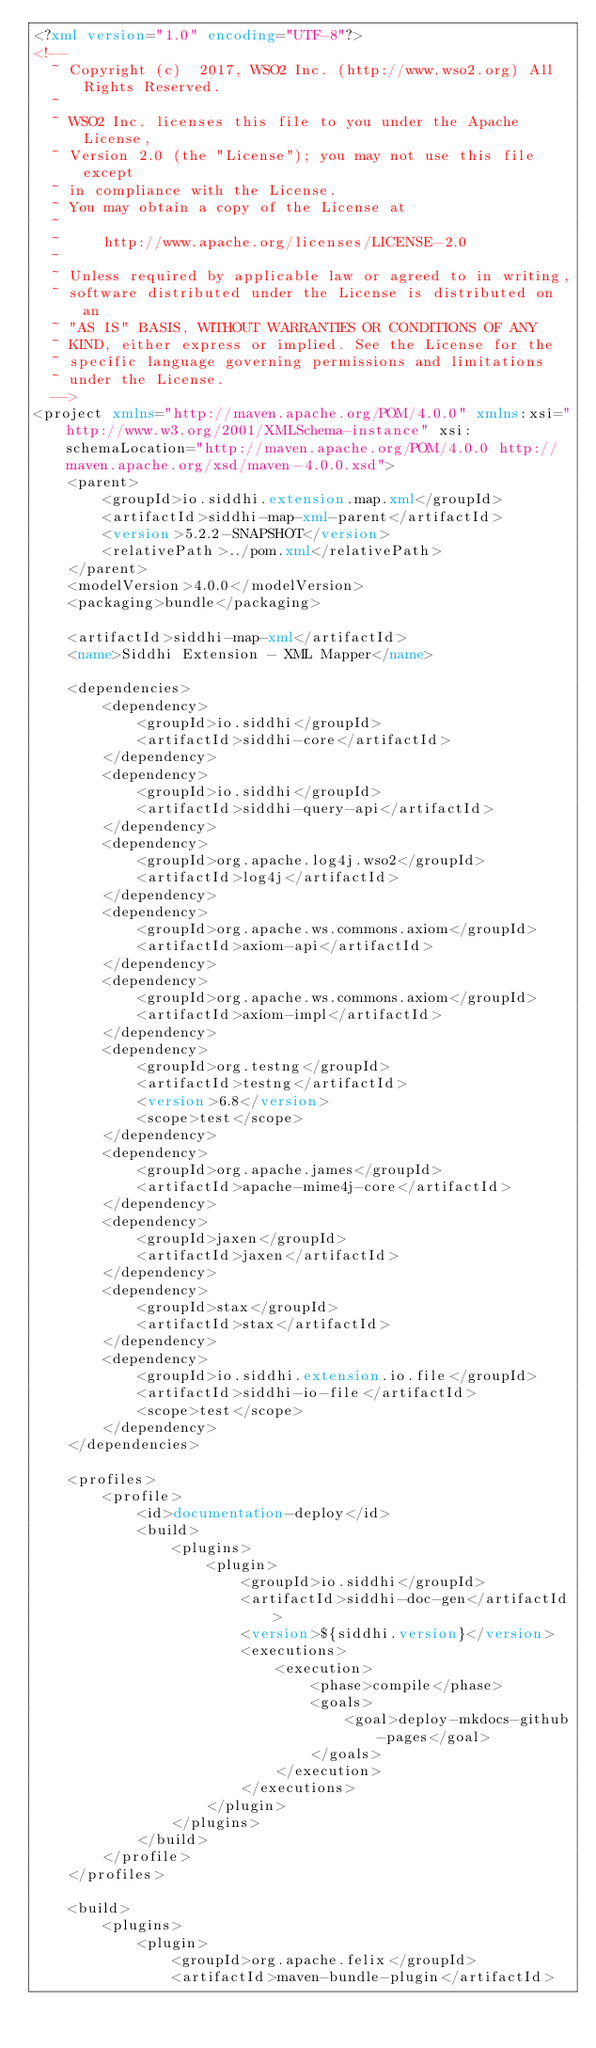<code> <loc_0><loc_0><loc_500><loc_500><_XML_><?xml version="1.0" encoding="UTF-8"?>
<!--
  ~ Copyright (c)  2017, WSO2 Inc. (http://www.wso2.org) All Rights Reserved.
  ~
  ~ WSO2 Inc. licenses this file to you under the Apache License,
  ~ Version 2.0 (the "License"); you may not use this file except
  ~ in compliance with the License.
  ~ You may obtain a copy of the License at
  ~
  ~     http://www.apache.org/licenses/LICENSE-2.0
  ~
  ~ Unless required by applicable law or agreed to in writing,
  ~ software distributed under the License is distributed on an
  ~ "AS IS" BASIS, WITHOUT WARRANTIES OR CONDITIONS OF ANY
  ~ KIND, either express or implied. See the License for the
  ~ specific language governing permissions and limitations
  ~ under the License.
  -->
<project xmlns="http://maven.apache.org/POM/4.0.0" xmlns:xsi="http://www.w3.org/2001/XMLSchema-instance" xsi:schemaLocation="http://maven.apache.org/POM/4.0.0 http://maven.apache.org/xsd/maven-4.0.0.xsd">
    <parent>
        <groupId>io.siddhi.extension.map.xml</groupId>
        <artifactId>siddhi-map-xml-parent</artifactId>
        <version>5.2.2-SNAPSHOT</version>
        <relativePath>../pom.xml</relativePath>
    </parent>
    <modelVersion>4.0.0</modelVersion>
    <packaging>bundle</packaging>

    <artifactId>siddhi-map-xml</artifactId>
    <name>Siddhi Extension - XML Mapper</name>

    <dependencies>
        <dependency>
            <groupId>io.siddhi</groupId>
            <artifactId>siddhi-core</artifactId>
        </dependency>
        <dependency>
            <groupId>io.siddhi</groupId>
            <artifactId>siddhi-query-api</artifactId>
        </dependency>
        <dependency>
            <groupId>org.apache.log4j.wso2</groupId>
            <artifactId>log4j</artifactId>
        </dependency>
        <dependency>
            <groupId>org.apache.ws.commons.axiom</groupId>
            <artifactId>axiom-api</artifactId>
        </dependency>
        <dependency>
            <groupId>org.apache.ws.commons.axiom</groupId>
            <artifactId>axiom-impl</artifactId>
        </dependency>
        <dependency>
            <groupId>org.testng</groupId>
            <artifactId>testng</artifactId>
            <version>6.8</version>
            <scope>test</scope>
        </dependency>
        <dependency>
            <groupId>org.apache.james</groupId>
            <artifactId>apache-mime4j-core</artifactId>
        </dependency>
        <dependency>
            <groupId>jaxen</groupId>
            <artifactId>jaxen</artifactId>
        </dependency>
        <dependency>
            <groupId>stax</groupId>
            <artifactId>stax</artifactId>
        </dependency>
        <dependency>
            <groupId>io.siddhi.extension.io.file</groupId>
            <artifactId>siddhi-io-file</artifactId>
            <scope>test</scope>
        </dependency>
    </dependencies>

    <profiles>
        <profile>
            <id>documentation-deploy</id>
            <build>
                <plugins>
                    <plugin>
                        <groupId>io.siddhi</groupId>
                        <artifactId>siddhi-doc-gen</artifactId>
                        <version>${siddhi.version}</version>
                        <executions>
                            <execution>
                                <phase>compile</phase>
                                <goals>
                                    <goal>deploy-mkdocs-github-pages</goal>
                                </goals>
                            </execution>
                        </executions>
                    </plugin>
                </plugins>
            </build>
        </profile>
    </profiles>

    <build>
        <plugins>
            <plugin>
                <groupId>org.apache.felix</groupId>
                <artifactId>maven-bundle-plugin</artifactId></code> 